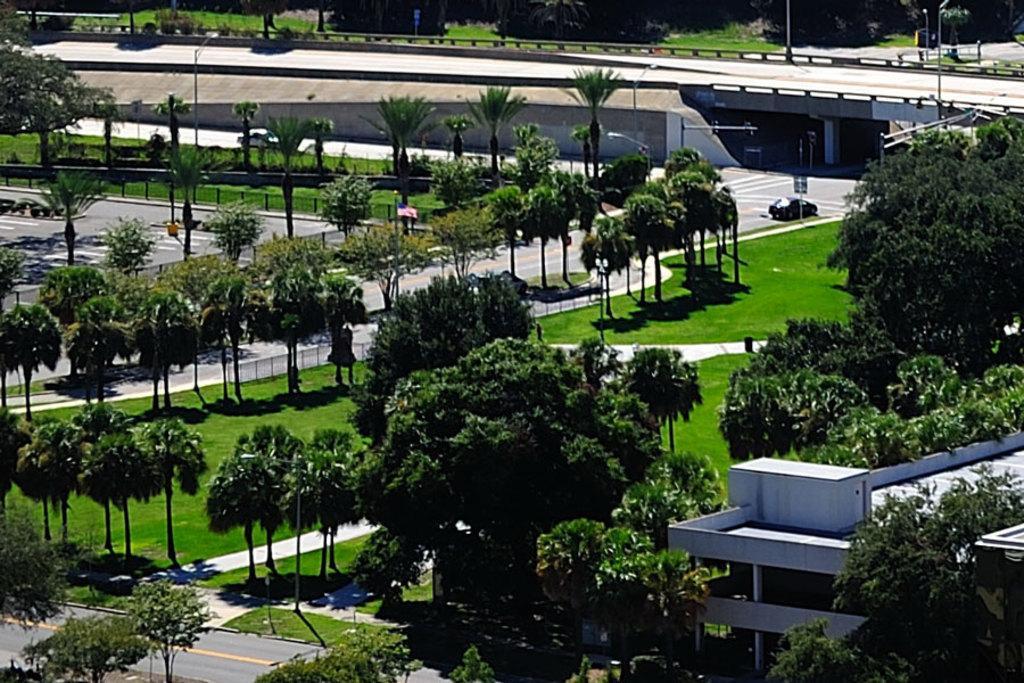Can you describe this image briefly? In this image I can see trees in green color, a building in white color, background I can see few vehicles on the road, a traffic signal and I can see a bridge. 